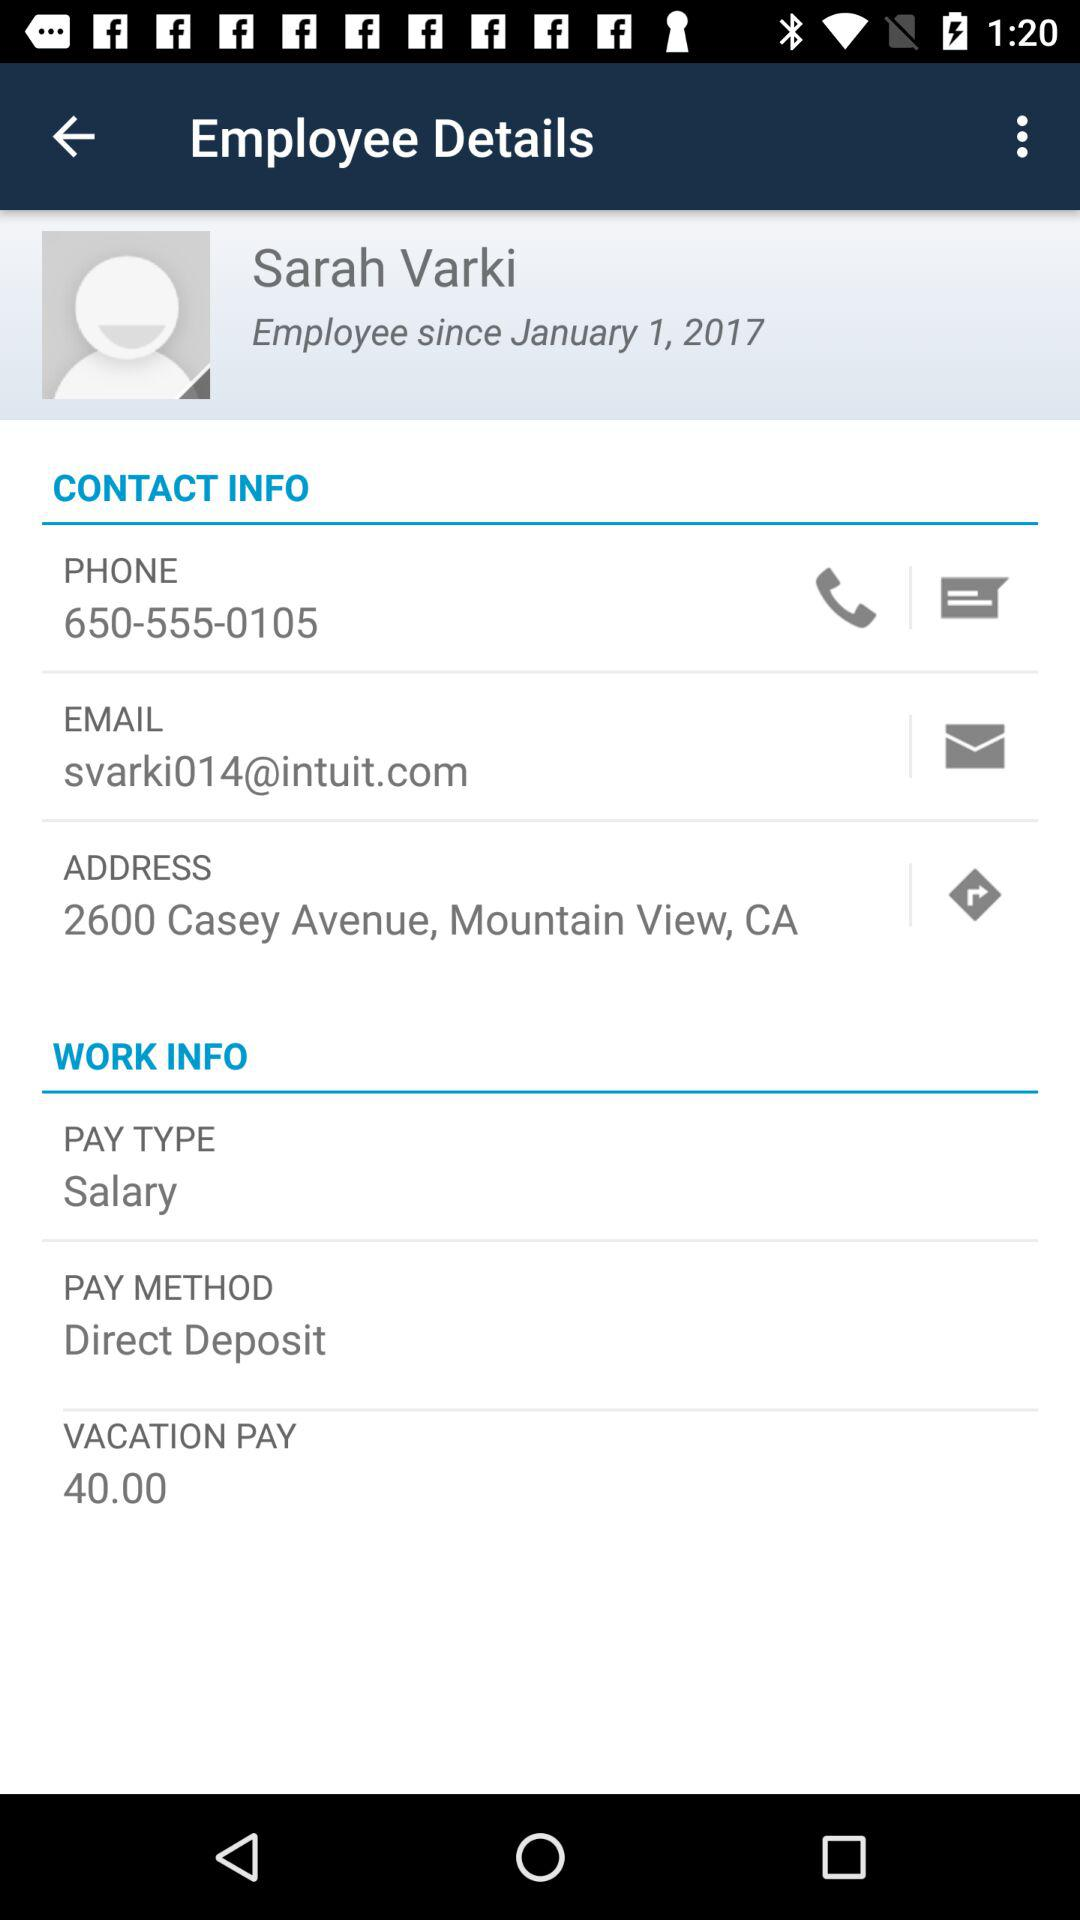What is Sarah Varki's email address?
Answer the question using a single word or phrase. Svarki014@intuit.com 